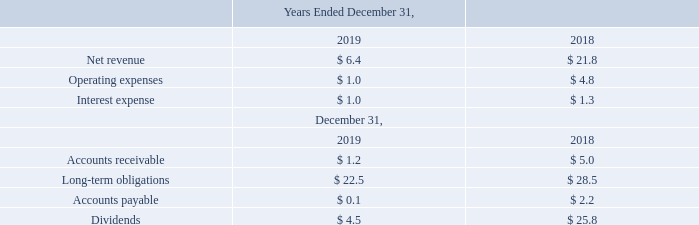In November 2017, GMSL acquired the trenching and cable laying services business from Fugro N.V. ("Fugro"). As part of the transaction, Fugro became a 23.6% holder of GMSL's parent, Global Marine Holdings, LLC ("GMH"). GMSL, in the normal course of business, incurred revenue and expenses with Fugro for various services.
For the years ended December 31, 2019 and 2018, GMSL recognized $11.3 million and $9.3 million respectively, of expenses for transactions with Fugro. For the year ended December 31, 2019 GMSL recognized $0.8 million of revenues. The parent company of GMSL, GMH, incurred management fees of $0.6 million for each of the years ended December 31, 2019 and 2018.
GMSL also has transactions with several of their equity method investees. A summary of transactions with such equity method investees and balances outstanding are as follows (in millions):
What percentage of Global Marine Holdings, LLC is owned by Fugro? 23.6%. What were the transaction expenses recognized by GMSL in 2019? $11.3 million. What was the net revenue in 2019? $ 6.4. What is the increase / (decrease) in the net revenue from 2018 to 2019?
Answer scale should be: million. 6.4 - 21.8
Answer: -15.4. What is the average operating expenses?
Answer scale should be: million. (1.0 + 4.8) / 2
Answer: 2.9. What is the average interest expense?
Answer scale should be: million. (1.0 + 1.3) / 2
Answer: 1.15. 